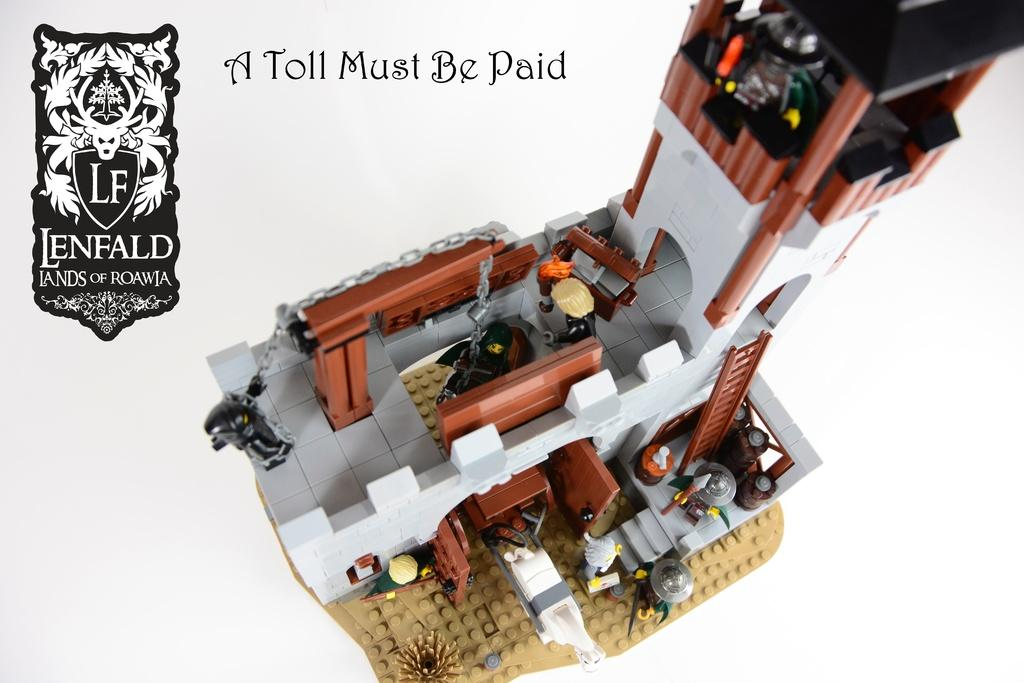What type of toys are depicted in the image? There are toys in the shape of a building in the image. What else can be seen in the image besides the toys? There is a logo and text written on the image. What is the color of the background in the image? The background of the image is white in color. How does the stranger care for the toys in the image? There is no stranger present in the image, so it is not possible to answer this question. 